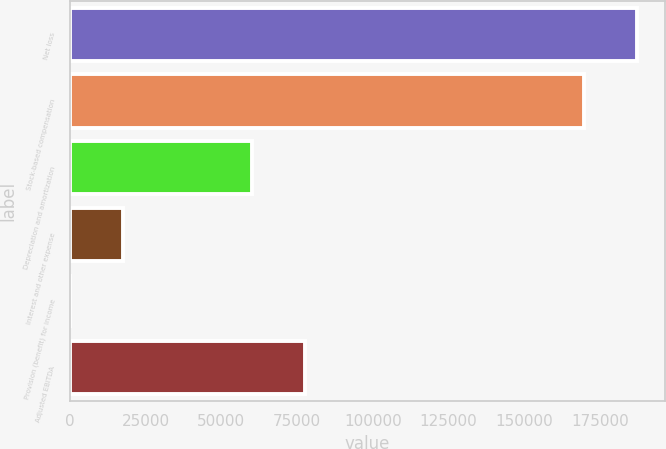Convert chart. <chart><loc_0><loc_0><loc_500><loc_500><bar_chart><fcel>Net loss<fcel>Stock-based compensation<fcel>Depreciation and amortization<fcel>Interest and other expense<fcel>Provision (benefit) for income<fcel>Adjusted EBITDA<nl><fcel>187132<fcel>169602<fcel>60155<fcel>17689.5<fcel>159<fcel>77685.5<nl></chart> 